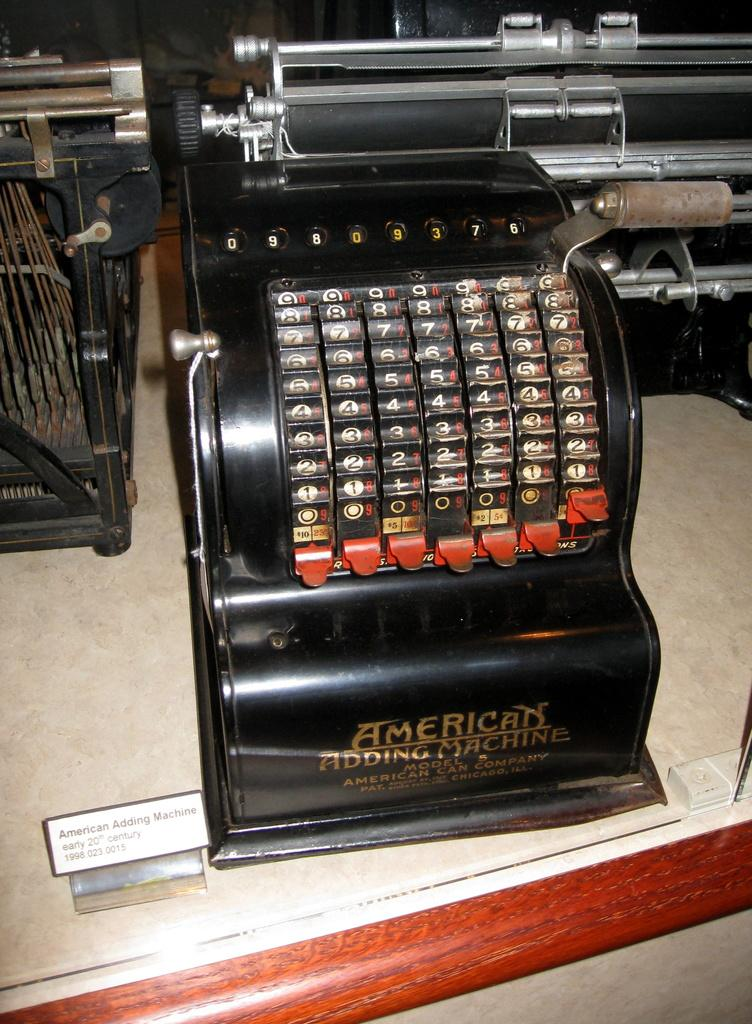<image>
Give a short and clear explanation of the subsequent image. An old black American Adding Machine sitting on a counter. 